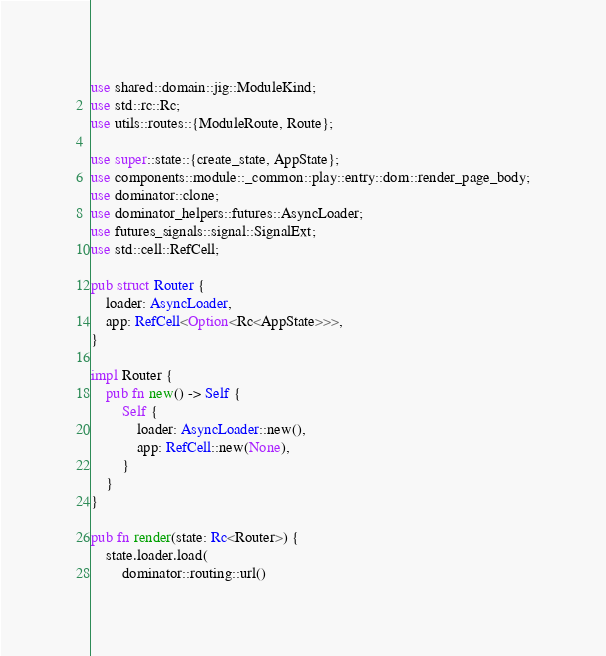<code> <loc_0><loc_0><loc_500><loc_500><_Rust_>use shared::domain::jig::ModuleKind;
use std::rc::Rc;
use utils::routes::{ModuleRoute, Route};

use super::state::{create_state, AppState};
use components::module::_common::play::entry::dom::render_page_body;
use dominator::clone;
use dominator_helpers::futures::AsyncLoader;
use futures_signals::signal::SignalExt;
use std::cell::RefCell;

pub struct Router {
    loader: AsyncLoader,
    app: RefCell<Option<Rc<AppState>>>,
}

impl Router {
    pub fn new() -> Self {
        Self {
            loader: AsyncLoader::new(),
            app: RefCell::new(None),
        }
    }
}

pub fn render(state: Rc<Router>) {
    state.loader.load(
        dominator::routing::url()</code> 